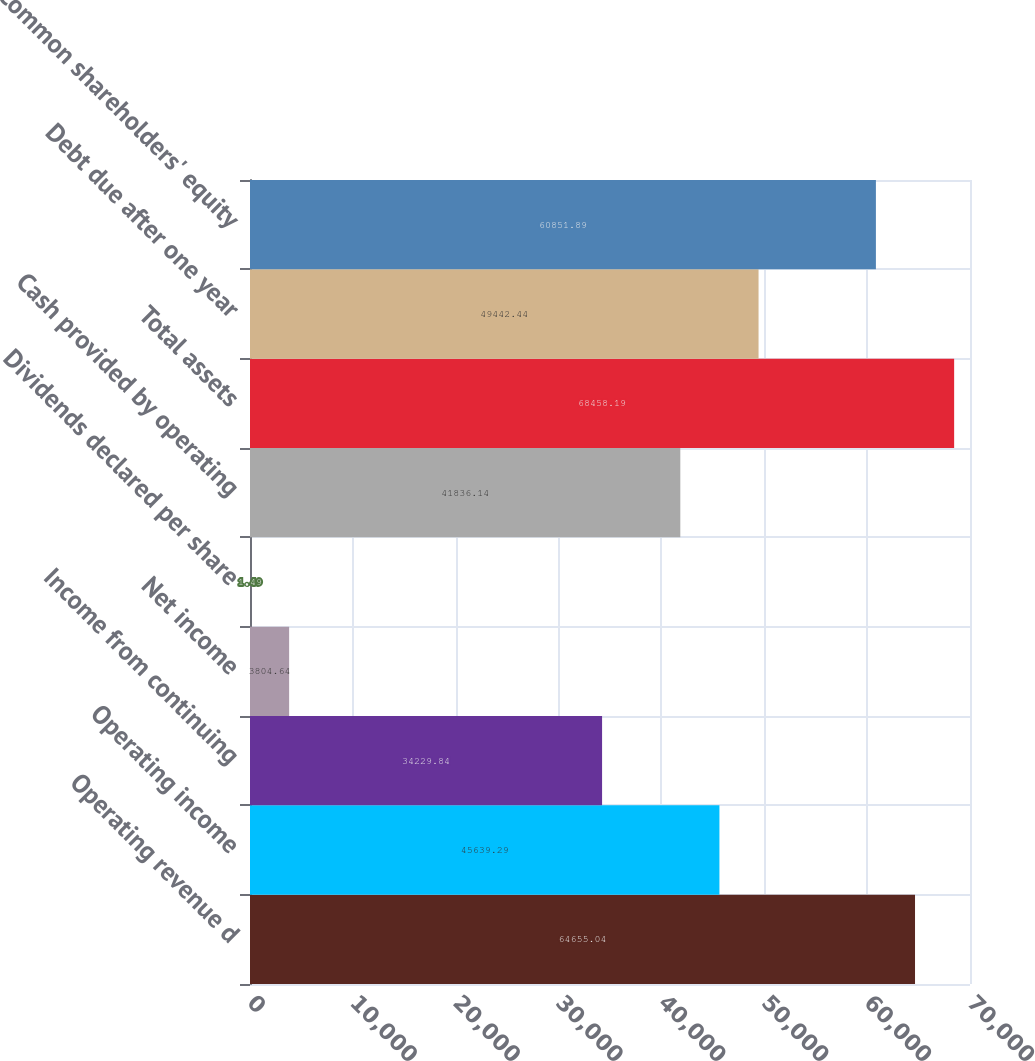<chart> <loc_0><loc_0><loc_500><loc_500><bar_chart><fcel>Operating revenue d<fcel>Operating income<fcel>Income from continuing<fcel>Net income<fcel>Dividends declared per share<fcel>Cash provided by operating<fcel>Total assets<fcel>Debt due after one year<fcel>Common shareholders' equity<nl><fcel>64655<fcel>45639.3<fcel>34229.8<fcel>3804.64<fcel>1.49<fcel>41836.1<fcel>68458.2<fcel>49442.4<fcel>60851.9<nl></chart> 